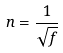Convert formula to latex. <formula><loc_0><loc_0><loc_500><loc_500>n = \frac { 1 } { \sqrt { f } }</formula> 